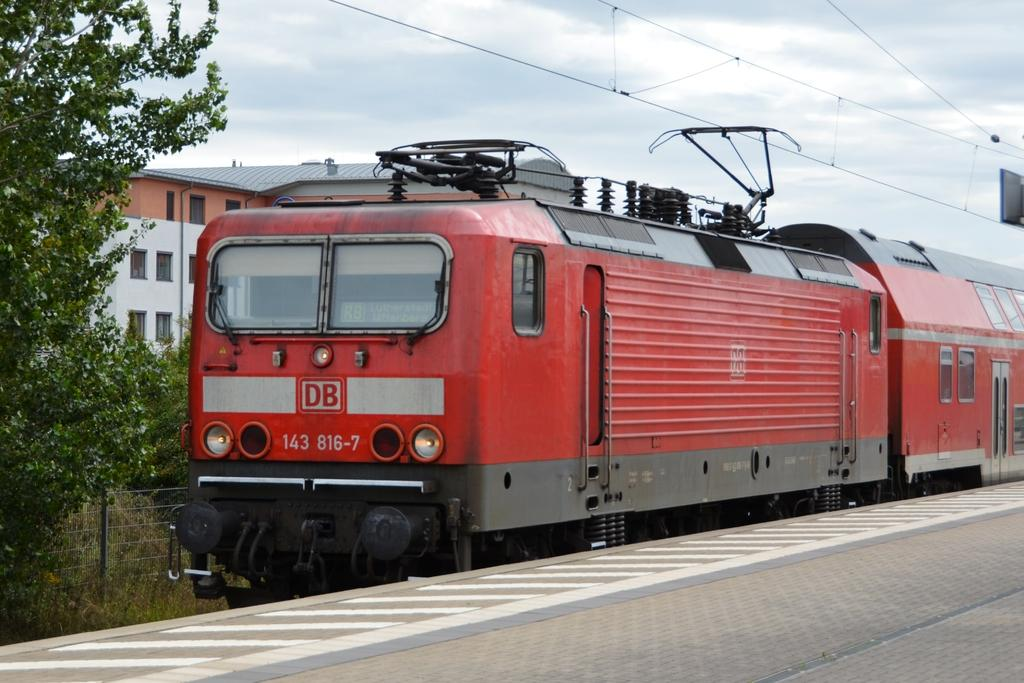Provide a one-sentence caption for the provided image. A red DB 143 816-7 train is sitting on the tracks. 